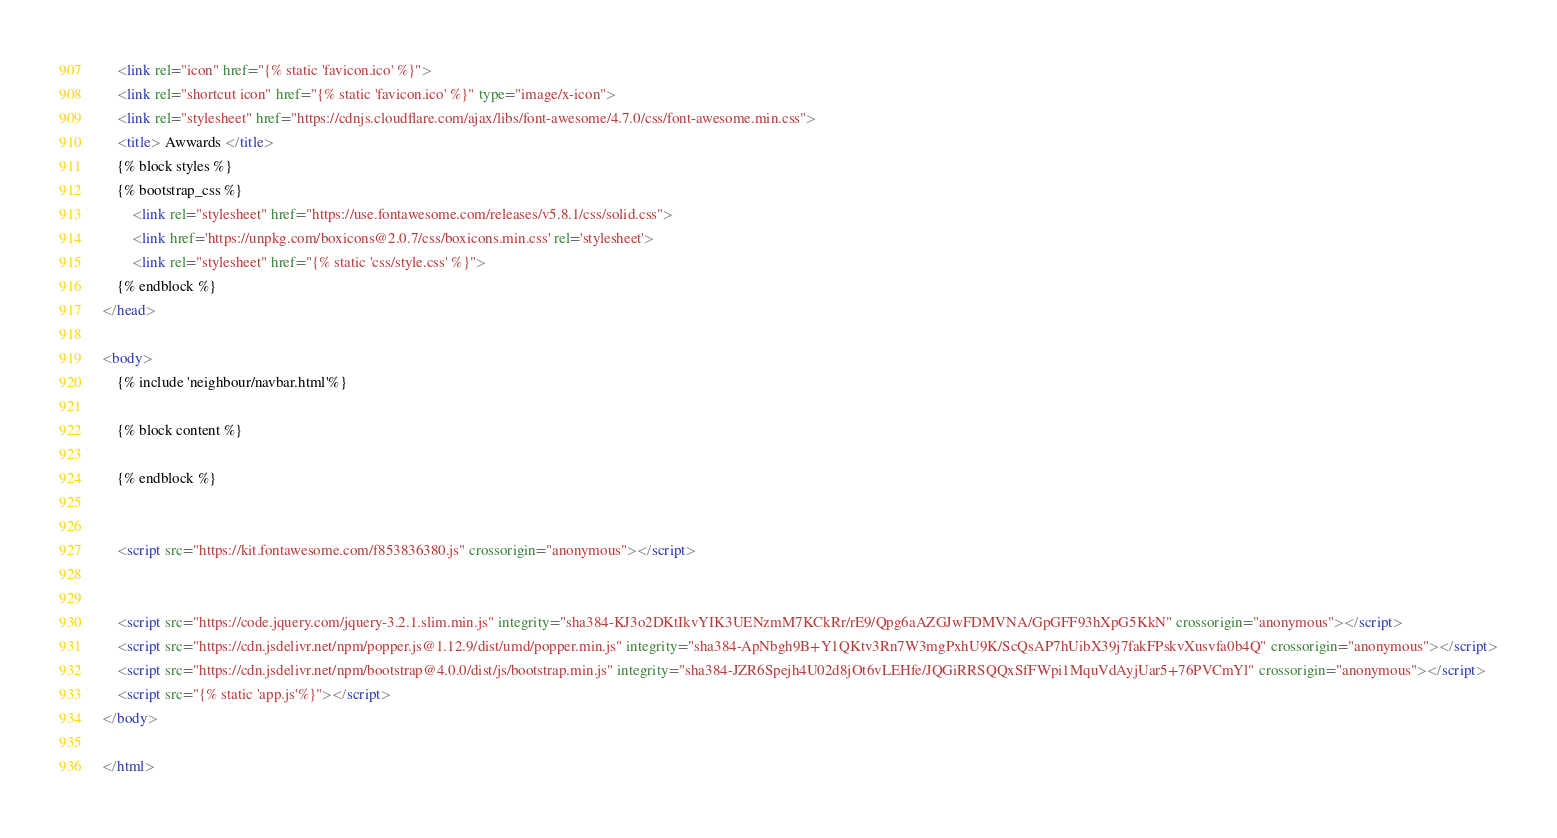<code> <loc_0><loc_0><loc_500><loc_500><_HTML_>    <link rel="icon" href="{% static 'favicon.ico' %}">
    <link rel="shortcut icon" href="{% static 'favicon.ico' %}" type="image/x-icon">
    <link rel="stylesheet" href="https://cdnjs.cloudflare.com/ajax/libs/font-awesome/4.7.0/css/font-awesome.min.css">
    <title> Awwards </title>
    {% block styles %}
    {% bootstrap_css %}
        <link rel="stylesheet" href="https://use.fontawesome.com/releases/v5.8.1/css/solid.css">
        <link href='https://unpkg.com/boxicons@2.0.7/css/boxicons.min.css' rel='stylesheet'>
        <link rel="stylesheet" href="{% static 'css/style.css' %}">
    {% endblock %}
</head>

<body>
    {% include 'neighbour/navbar.html'%}
    
    {% block content %}

    {% endblock %}


    <script src="https://kit.fontawesome.com/f853836380.js" crossorigin="anonymous"></script>

    
    <script src="https://code.jquery.com/jquery-3.2.1.slim.min.js" integrity="sha384-KJ3o2DKtIkvYIK3UENzmM7KCkRr/rE9/Qpg6aAZGJwFDMVNA/GpGFF93hXpG5KkN" crossorigin="anonymous"></script>
    <script src="https://cdn.jsdelivr.net/npm/popper.js@1.12.9/dist/umd/popper.min.js" integrity="sha384-ApNbgh9B+Y1QKtv3Rn7W3mgPxhU9K/ScQsAP7hUibX39j7fakFPskvXusvfa0b4Q" crossorigin="anonymous"></script>
    <script src="https://cdn.jsdelivr.net/npm/bootstrap@4.0.0/dist/js/bootstrap.min.js" integrity="sha384-JZR6Spejh4U02d8jOt6vLEHfe/JQGiRRSQQxSfFWpi1MquVdAyjUar5+76PVCmYl" crossorigin="anonymous"></script>
    <script src="{% static 'app.js'%}"></script>
</body>

</html></code> 